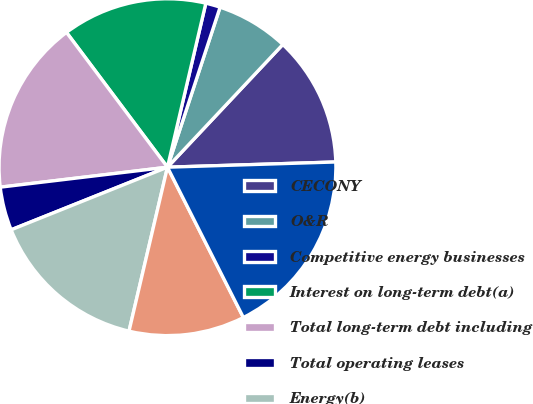<chart> <loc_0><loc_0><loc_500><loc_500><pie_chart><fcel>CECONY<fcel>O&R<fcel>Competitive energy businesses<fcel>Interest on long-term debt(a)<fcel>Total long-term debt including<fcel>Total operating leases<fcel>Energy(b)<fcel>Capacity<fcel>Total CECONY<nl><fcel>12.5%<fcel>6.95%<fcel>1.4%<fcel>13.89%<fcel>16.66%<fcel>4.17%<fcel>15.27%<fcel>11.11%<fcel>18.05%<nl></chart> 